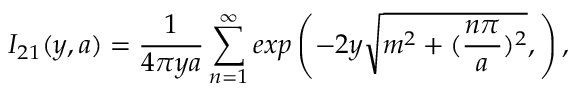Convert formula to latex. <formula><loc_0><loc_0><loc_500><loc_500>I _ { 2 1 } ( y , a ) = \frac { 1 } { 4 \pi y a } \sum _ { n = 1 } ^ { \infty } e x p \left ( - 2 y \sqrt { m ^ { 2 } + ( \frac { n \pi } { a } ) ^ { 2 } } , \right ) ,</formula> 